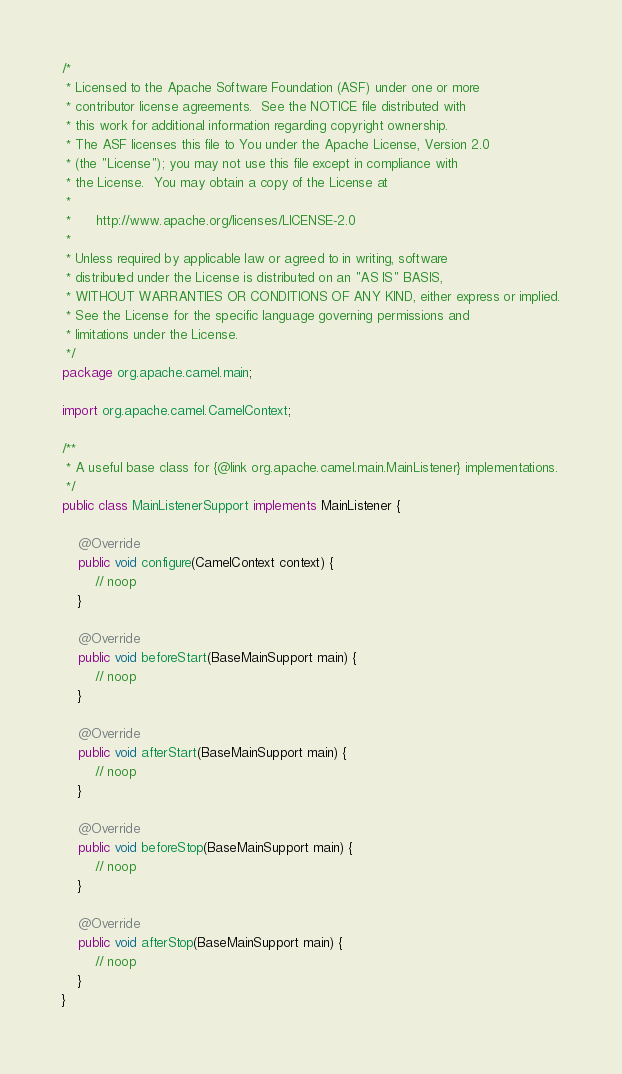<code> <loc_0><loc_0><loc_500><loc_500><_Java_>/*
 * Licensed to the Apache Software Foundation (ASF) under one or more
 * contributor license agreements.  See the NOTICE file distributed with
 * this work for additional information regarding copyright ownership.
 * The ASF licenses this file to You under the Apache License, Version 2.0
 * (the "License"); you may not use this file except in compliance with
 * the License.  You may obtain a copy of the License at
 *
 *      http://www.apache.org/licenses/LICENSE-2.0
 *
 * Unless required by applicable law or agreed to in writing, software
 * distributed under the License is distributed on an "AS IS" BASIS,
 * WITHOUT WARRANTIES OR CONDITIONS OF ANY KIND, either express or implied.
 * See the License for the specific language governing permissions and
 * limitations under the License.
 */
package org.apache.camel.main;

import org.apache.camel.CamelContext;

/**
 * A useful base class for {@link org.apache.camel.main.MainListener} implementations.
 */
public class MainListenerSupport implements MainListener {

    @Override
    public void configure(CamelContext context) {
        // noop
    }

    @Override
    public void beforeStart(BaseMainSupport main) {
        // noop
    }

    @Override
    public void afterStart(BaseMainSupport main) {
        // noop
    }

    @Override
    public void beforeStop(BaseMainSupport main) {
        // noop
    }

    @Override
    public void afterStop(BaseMainSupport main) {
        // noop
    }
}
</code> 